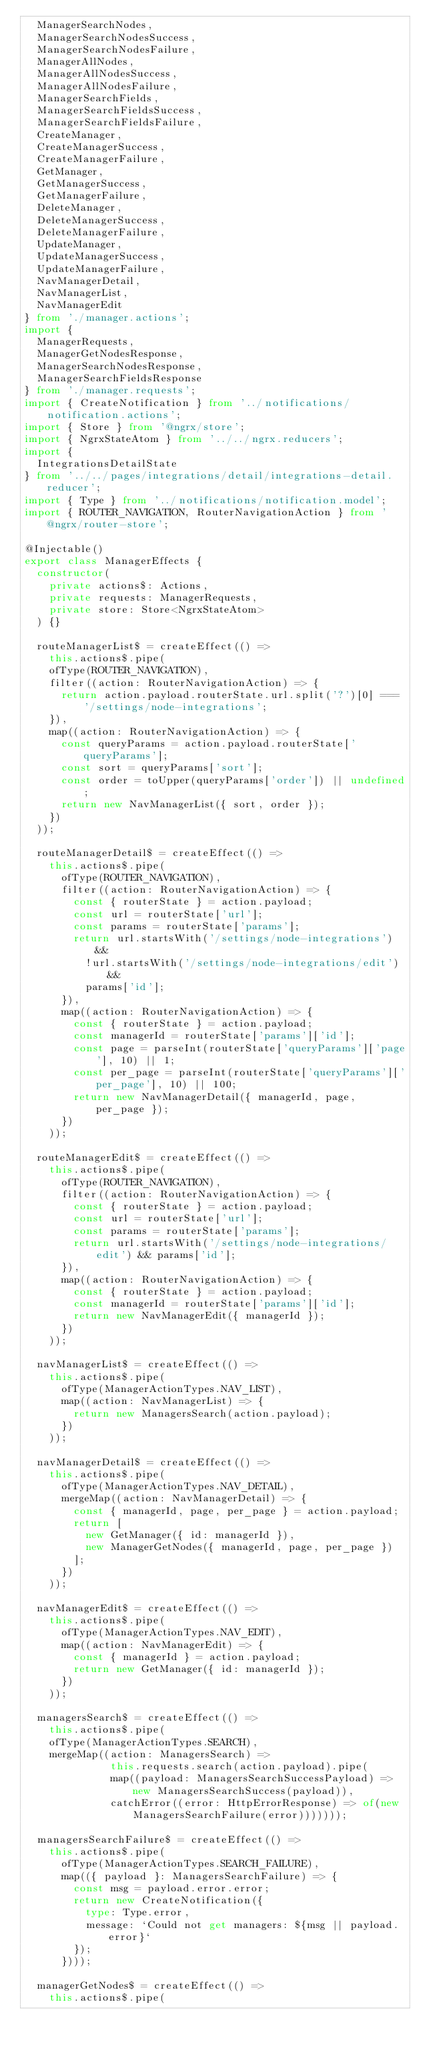<code> <loc_0><loc_0><loc_500><loc_500><_TypeScript_>  ManagerSearchNodes,
  ManagerSearchNodesSuccess,
  ManagerSearchNodesFailure,
  ManagerAllNodes,
  ManagerAllNodesSuccess,
  ManagerAllNodesFailure,
  ManagerSearchFields,
  ManagerSearchFieldsSuccess,
  ManagerSearchFieldsFailure,
  CreateManager,
  CreateManagerSuccess,
  CreateManagerFailure,
  GetManager,
  GetManagerSuccess,
  GetManagerFailure,
  DeleteManager,
  DeleteManagerSuccess,
  DeleteManagerFailure,
  UpdateManager,
  UpdateManagerSuccess,
  UpdateManagerFailure,
  NavManagerDetail,
  NavManagerList,
  NavManagerEdit
} from './manager.actions';
import {
  ManagerRequests,
  ManagerGetNodesResponse,
  ManagerSearchNodesResponse,
  ManagerSearchFieldsResponse
} from './manager.requests';
import { CreateNotification } from '../notifications/notification.actions';
import { Store } from '@ngrx/store';
import { NgrxStateAtom } from '../../ngrx.reducers';
import {
  IntegrationsDetailState
} from '../../pages/integrations/detail/integrations-detail.reducer';
import { Type } from '../notifications/notification.model';
import { ROUTER_NAVIGATION, RouterNavigationAction } from '@ngrx/router-store';

@Injectable()
export class ManagerEffects {
  constructor(
    private actions$: Actions,
    private requests: ManagerRequests,
    private store: Store<NgrxStateAtom>
  ) {}

  routeManagerList$ = createEffect(() =>
    this.actions$.pipe(
    ofType(ROUTER_NAVIGATION),
    filter((action: RouterNavigationAction) => {
      return action.payload.routerState.url.split('?')[0] === '/settings/node-integrations';
    }),
    map((action: RouterNavigationAction) => {
      const queryParams = action.payload.routerState['queryParams'];
      const sort = queryParams['sort'];
      const order = toUpper(queryParams['order']) || undefined;
      return new NavManagerList({ sort, order });
    })
  ));

  routeManagerDetail$ = createEffect(() =>
    this.actions$.pipe(
      ofType(ROUTER_NAVIGATION),
      filter((action: RouterNavigationAction) => {
        const { routerState } = action.payload;
        const url = routerState['url'];
        const params = routerState['params'];
        return url.startsWith('/settings/node-integrations') &&
          !url.startsWith('/settings/node-integrations/edit') &&
          params['id'];
      }),
      map((action: RouterNavigationAction) => {
        const { routerState } = action.payload;
        const managerId = routerState['params']['id'];
        const page = parseInt(routerState['queryParams']['page'], 10) || 1;
        const per_page = parseInt(routerState['queryParams']['per_page'], 10) || 100;
        return new NavManagerDetail({ managerId, page, per_page });
      })
    ));

  routeManagerEdit$ = createEffect(() =>
    this.actions$.pipe(
      ofType(ROUTER_NAVIGATION),
      filter((action: RouterNavigationAction) => {
        const { routerState } = action.payload;
        const url = routerState['url'];
        const params = routerState['params'];
        return url.startsWith('/settings/node-integrations/edit') && params['id'];
      }),
      map((action: RouterNavigationAction) => {
        const { routerState } = action.payload;
        const managerId = routerState['params']['id'];
        return new NavManagerEdit({ managerId });
      })
    ));

  navManagerList$ = createEffect(() =>
    this.actions$.pipe(
      ofType(ManagerActionTypes.NAV_LIST),
      map((action: NavManagerList) => {
        return new ManagersSearch(action.payload);
      })
    ));

  navManagerDetail$ = createEffect(() =>
    this.actions$.pipe(
      ofType(ManagerActionTypes.NAV_DETAIL),
      mergeMap((action: NavManagerDetail) => {
        const { managerId, page, per_page } = action.payload;
        return [
          new GetManager({ id: managerId }),
          new ManagerGetNodes({ managerId, page, per_page })
        ];
      })
    ));

  navManagerEdit$ = createEffect(() =>
    this.actions$.pipe(
      ofType(ManagerActionTypes.NAV_EDIT),
      map((action: NavManagerEdit) => {
        const { managerId } = action.payload;
        return new GetManager({ id: managerId });
      })
    ));

  managersSearch$ = createEffect(() =>
    this.actions$.pipe(
    ofType(ManagerActionTypes.SEARCH),
    mergeMap((action: ManagersSearch) =>
              this.requests.search(action.payload).pipe(
              map((payload: ManagersSearchSuccessPayload) => new ManagersSearchSuccess(payload)),
              catchError((error: HttpErrorResponse) => of(new ManagersSearchFailure(error)))))));

  managersSearchFailure$ = createEffect(() =>
    this.actions$.pipe(
      ofType(ManagerActionTypes.SEARCH_FAILURE),
      map(({ payload }: ManagersSearchFailure) => {
        const msg = payload.error.error;
        return new CreateNotification({
          type: Type.error,
          message: `Could not get managers: ${msg || payload.error}`
        });
      })));

  managerGetNodes$ = createEffect(() =>
    this.actions$.pipe(</code> 